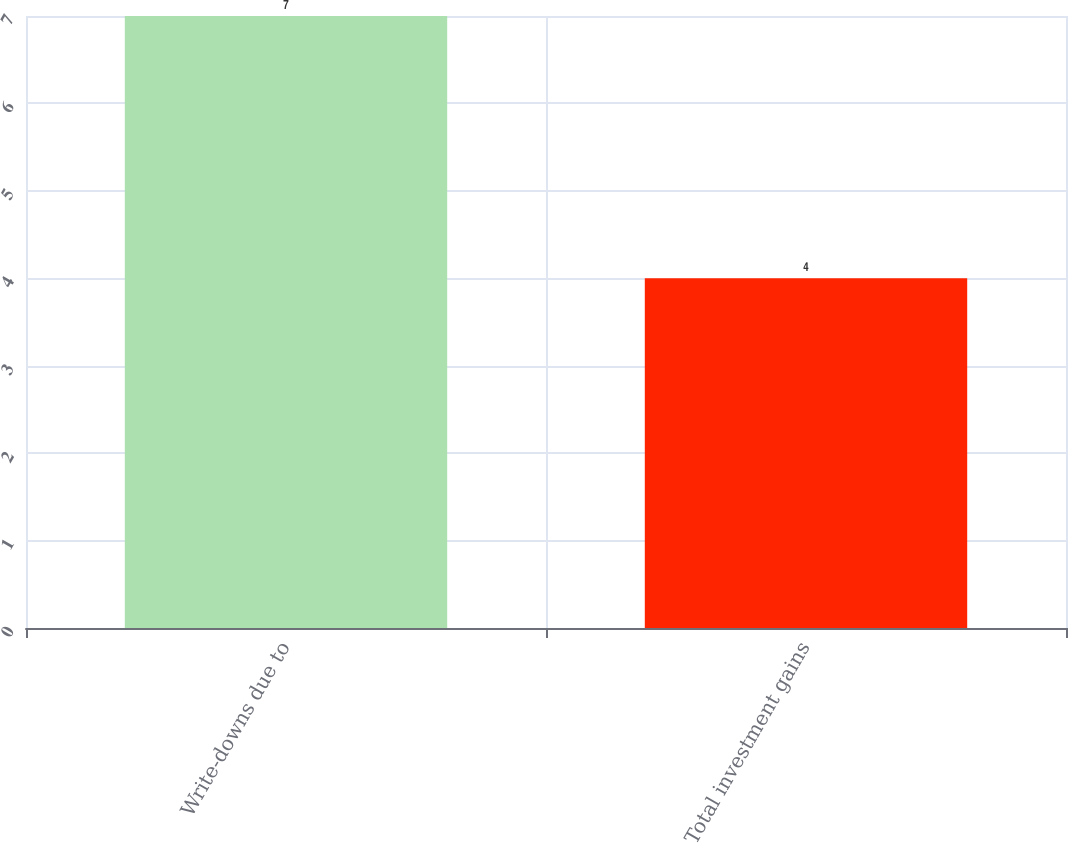Convert chart. <chart><loc_0><loc_0><loc_500><loc_500><bar_chart><fcel>Write-downs due to<fcel>Total investment gains<nl><fcel>7<fcel>4<nl></chart> 